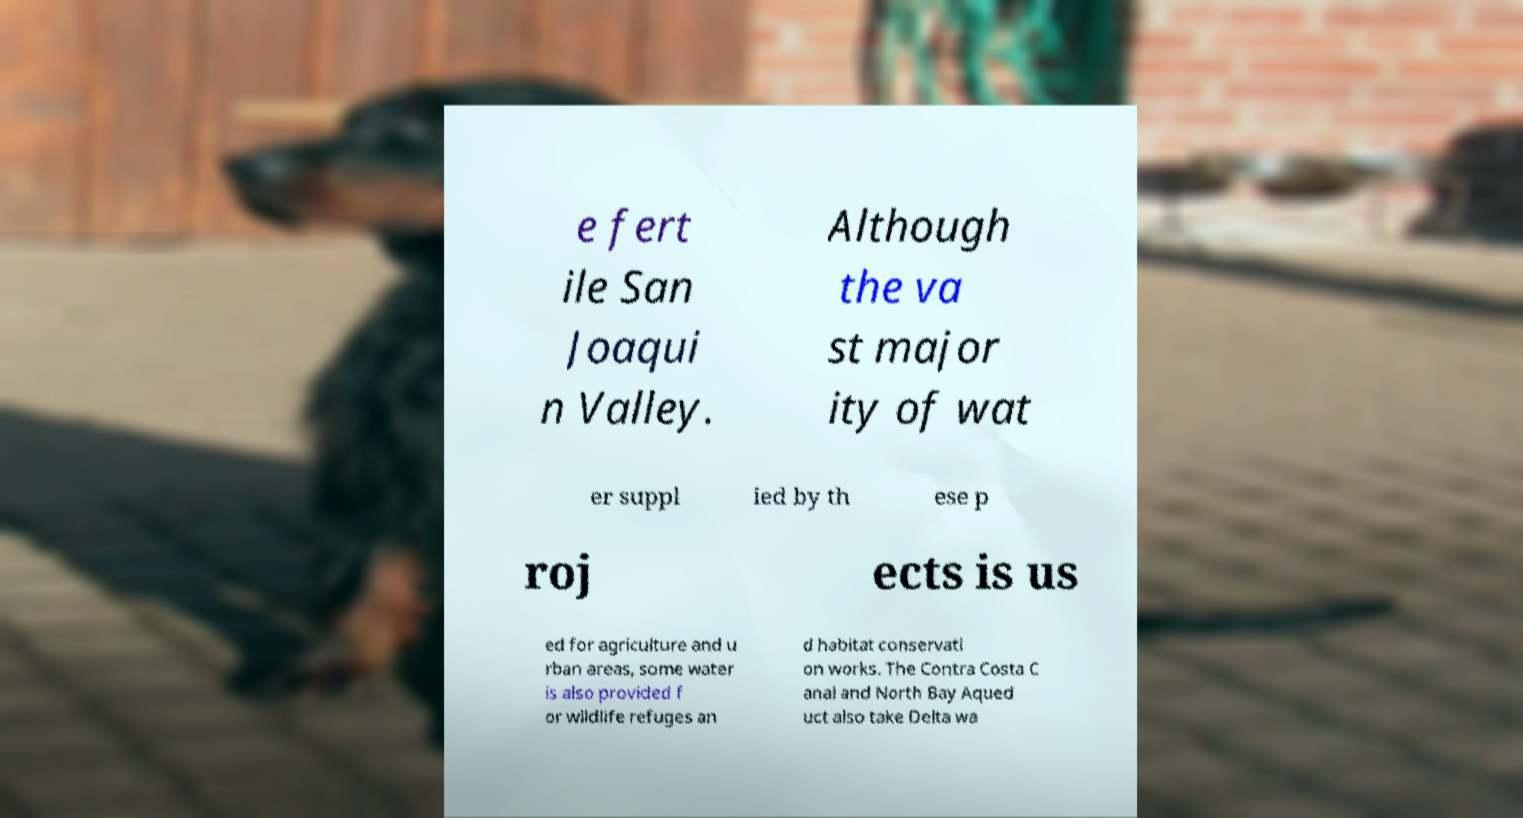Could you assist in decoding the text presented in this image and type it out clearly? e fert ile San Joaqui n Valley. Although the va st major ity of wat er suppl ied by th ese p roj ects is us ed for agriculture and u rban areas, some water is also provided f or wildlife refuges an d habitat conservati on works. The Contra Costa C anal and North Bay Aqued uct also take Delta wa 